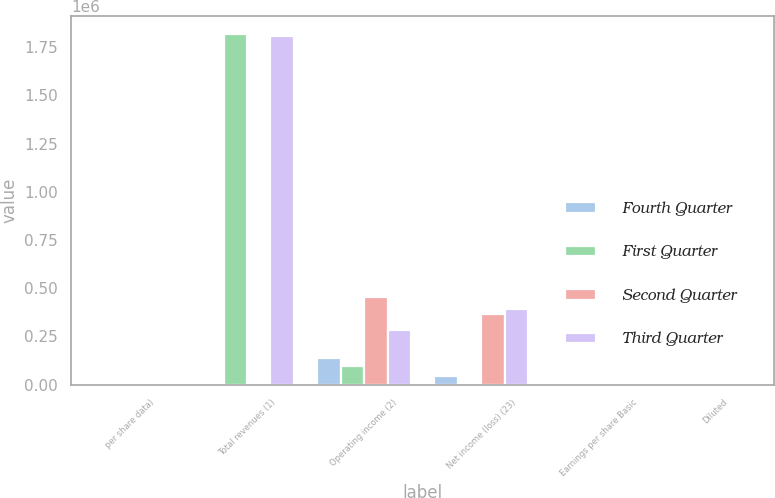Convert chart. <chart><loc_0><loc_0><loc_500><loc_500><stacked_bar_chart><ecel><fcel>per share data)<fcel>Total revenues (1)<fcel>Operating income (2)<fcel>Net income (loss) (23)<fcel>Earnings per share Basic<fcel>Diluted<nl><fcel>Fourth Quarter<fcel>2012<fcel>2012<fcel>135375<fcel>46964<fcel>0.22<fcel>0.21<nl><fcel>First Quarter<fcel>2012<fcel>1.821e+06<fcel>96905<fcel>3653<fcel>0.02<fcel>0.02<nl><fcel>Second Quarter<fcel>2012<fcel>2012<fcel>452137<fcel>367779<fcel>1.69<fcel>1.68<nl><fcel>Third Quarter<fcel>2012<fcel>1.80615e+06<fcel>281307<fcel>392803<fcel>1.8<fcel>1.8<nl></chart> 